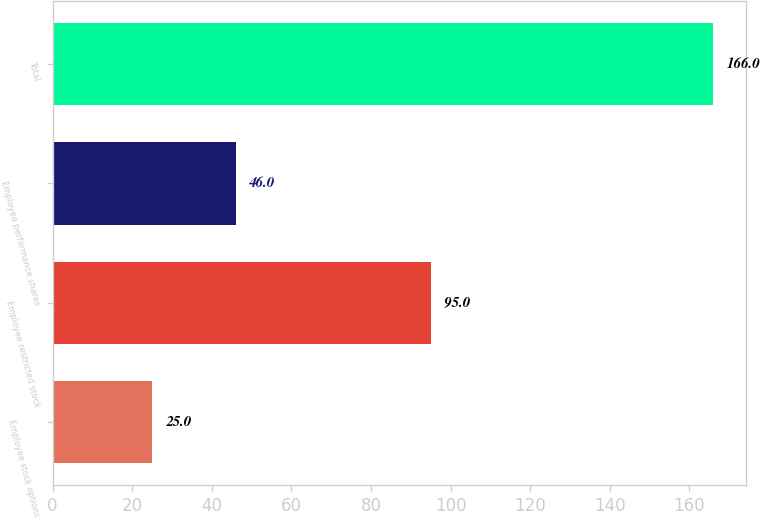Convert chart to OTSL. <chart><loc_0><loc_0><loc_500><loc_500><bar_chart><fcel>Employee stock options<fcel>Employee restricted stock<fcel>Employee performance shares<fcel>Total<nl><fcel>25<fcel>95<fcel>46<fcel>166<nl></chart> 